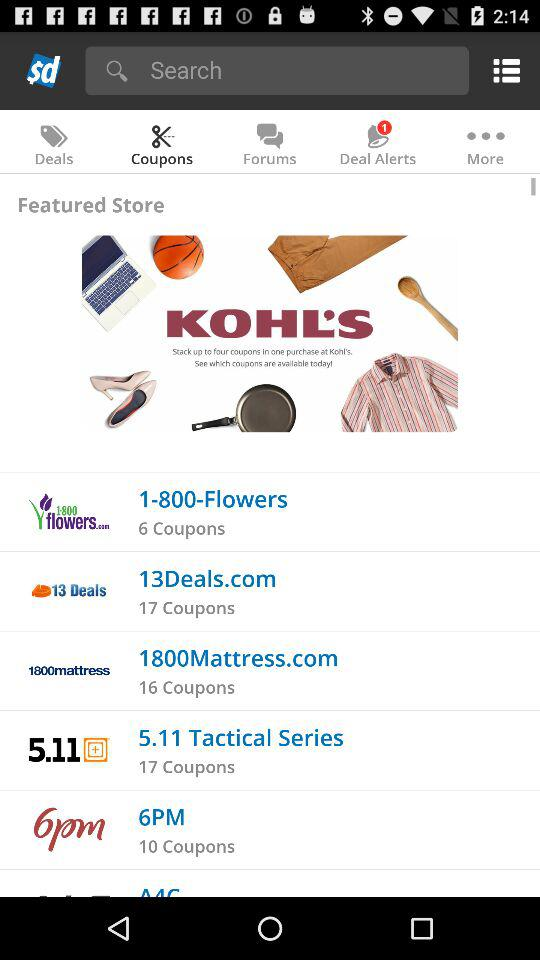What is the website of "1800mattress"? The website is 1800Mattress.com. 